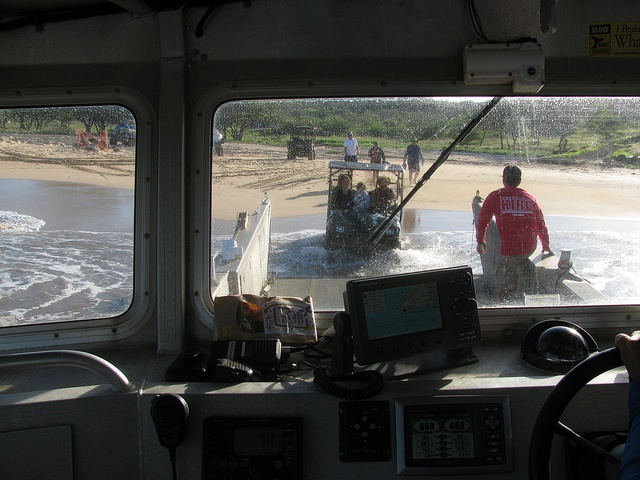Describe the objects in this image and their specific colors. I can see boat in black, gray, darkgray, lightgray, and tan tones, people in black, maroon, gray, and brown tones, car in black and gray tones, people in black and gray tones, and people in black and gray tones in this image. 